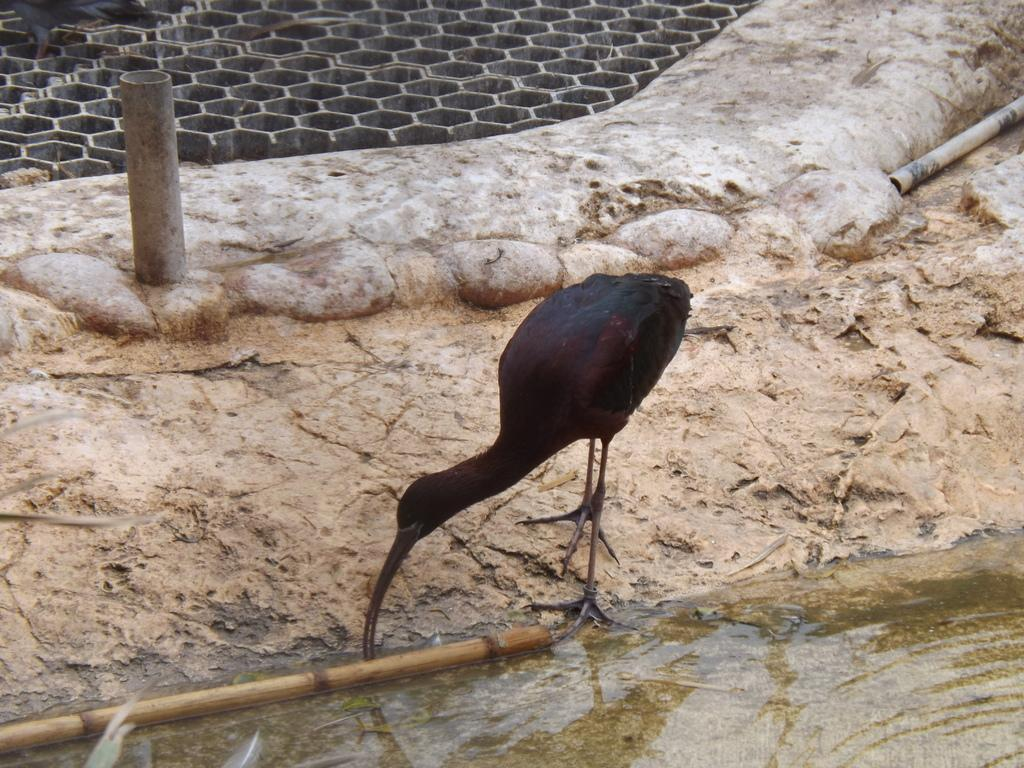What type of animal can be seen in the image? There is a bird in the image. What is the bird situated in? The bird is situated in water. What object is also present in the water? There is a stick in the water. Can you describe any other objects in the image? There are unspecified objects in the image. What route does the bird take to reach the farmer in the image? There is no farmer present in the image, and therefore no route for the bird to reach a farmer. 